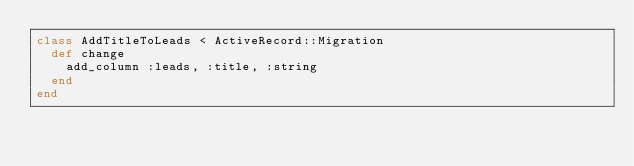<code> <loc_0><loc_0><loc_500><loc_500><_Ruby_>class AddTitleToLeads < ActiveRecord::Migration
  def change
    add_column :leads, :title, :string
  end
end
</code> 